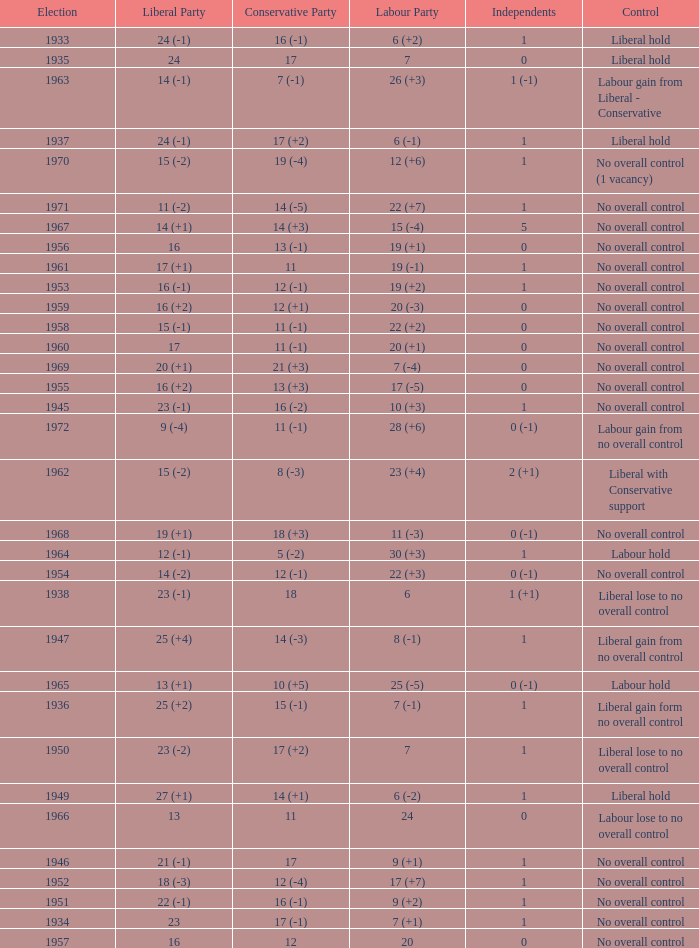What is the number of Independents elected in the year Labour won 26 (+3) seats? 1 (-1). 